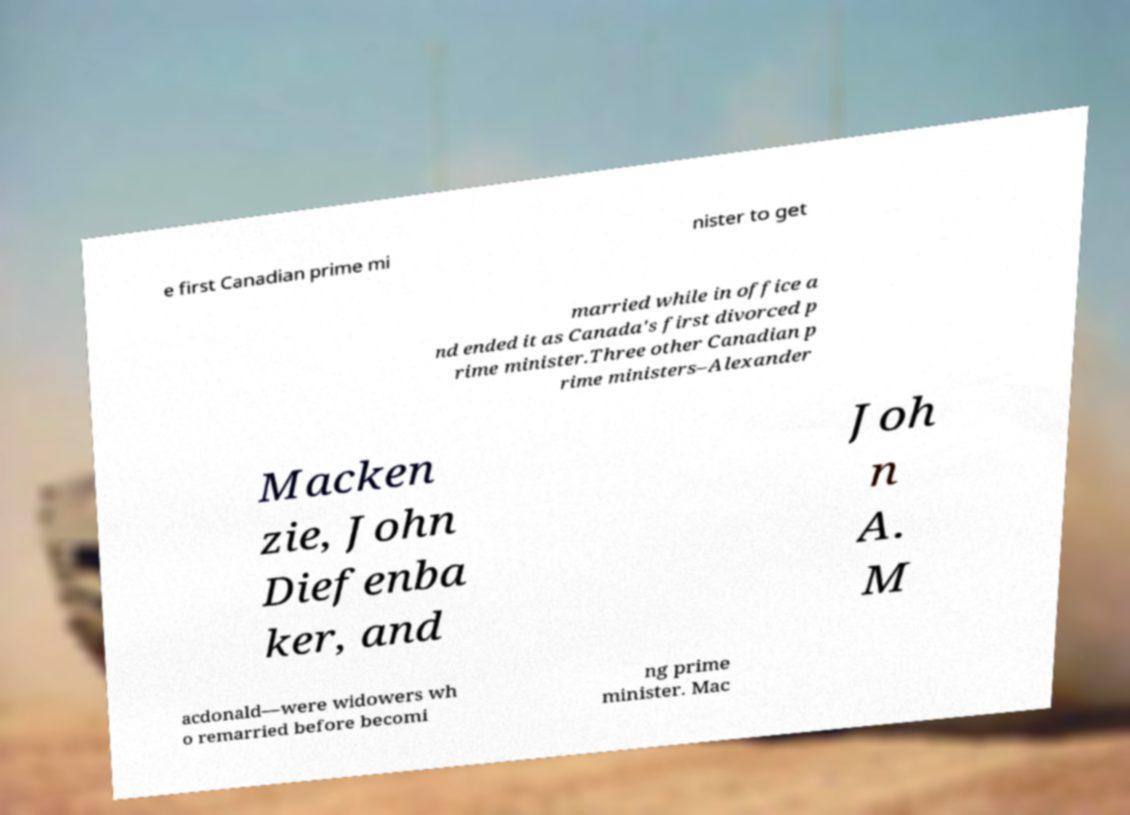Can you accurately transcribe the text from the provided image for me? e first Canadian prime mi nister to get married while in office a nd ended it as Canada's first divorced p rime minister.Three other Canadian p rime ministers–Alexander Macken zie, John Diefenba ker, and Joh n A. M acdonald—were widowers wh o remarried before becomi ng prime minister. Mac 